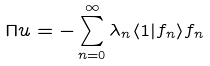<formula> <loc_0><loc_0><loc_500><loc_500>\Pi u = - \sum _ { n = 0 } ^ { \infty } \lambda _ { n } \langle 1 | f _ { n } \rangle f _ { n }</formula> 